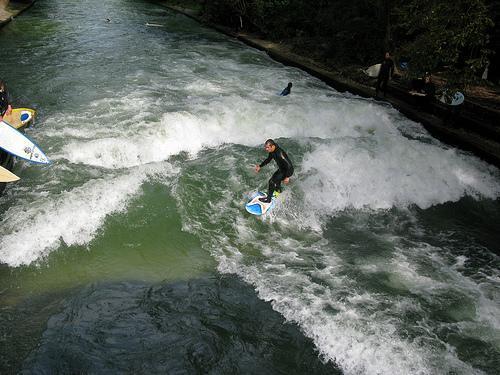How many people are standing on surfboards?
Give a very brief answer. 1. How many surfboards can be seen?
Give a very brief answer. 5. How many people are sitting?
Give a very brief answer. 1. 